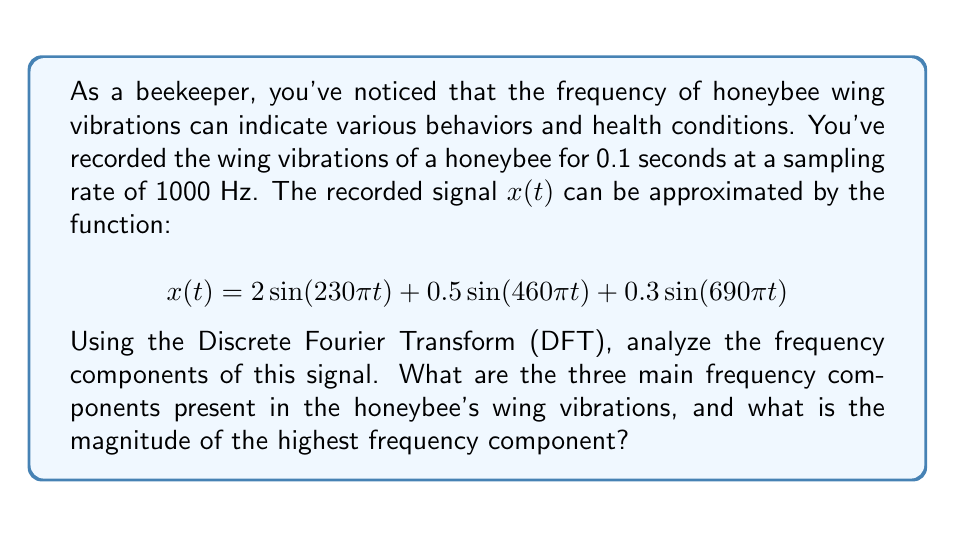Can you answer this question? Let's approach this step-by-step:

1) First, we need to identify the frequencies in the given function. For a sinusoidal function $\sin(2\pi ft)$, the frequency $f$ is given by the coefficient of $t$ divided by $2\pi$. So:

   For $2\sin(230\pi t)$: $f_1 = 230\pi/(2\pi) = 115$ Hz
   For $0.5\sin(460\pi t)$: $f_2 = 460\pi/(2\pi) = 230$ Hz
   For $0.3\sin(690\pi t)$: $f_3 = 690\pi/(2\pi) = 345$ Hz

2) These are the three main frequency components in the signal.

3) To find the magnitude of each component, we look at the coefficient of each sine term:

   For 115 Hz: magnitude = 2
   For 230 Hz: magnitude = 0.5
   For 345 Hz: magnitude = 0.3

4) The highest frequency component is 345 Hz, with a magnitude of 0.3.

5) In a DFT, these magnitudes would appear as peaks at these specific frequencies. The DFT would also show that these are the only significant frequency components in the signal.

6) Note that in a real DFT of a sampled signal, we would see these peaks, possibly with some spectral leakage, and the spectrum would be symmetric about the Nyquist frequency (500 Hz in this case, as the sampling rate is 1000 Hz).
Answer: The three main frequency components are 115 Hz, 230 Hz, and 345 Hz. The magnitude of the highest frequency component (345 Hz) is 0.3. 